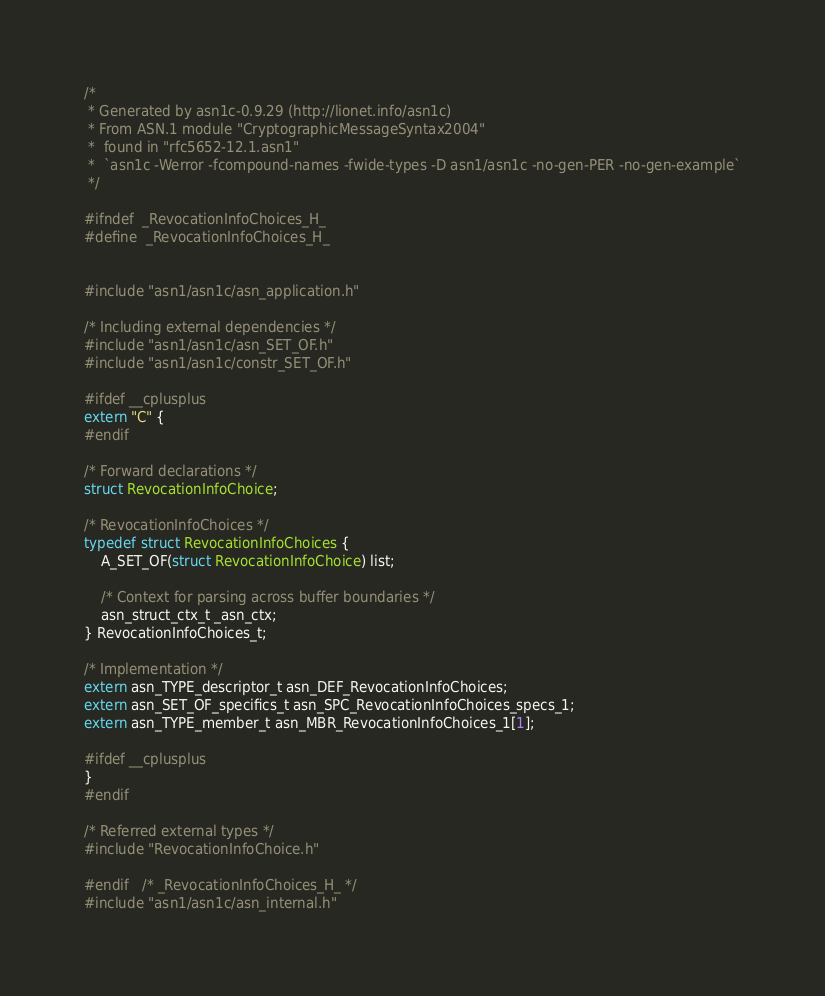<code> <loc_0><loc_0><loc_500><loc_500><_C_>/*
 * Generated by asn1c-0.9.29 (http://lionet.info/asn1c)
 * From ASN.1 module "CryptographicMessageSyntax2004"
 * 	found in "rfc5652-12.1.asn1"
 * 	`asn1c -Werror -fcompound-names -fwide-types -D asn1/asn1c -no-gen-PER -no-gen-example`
 */

#ifndef	_RevocationInfoChoices_H_
#define	_RevocationInfoChoices_H_


#include "asn1/asn1c/asn_application.h"

/* Including external dependencies */
#include "asn1/asn1c/asn_SET_OF.h"
#include "asn1/asn1c/constr_SET_OF.h"

#ifdef __cplusplus
extern "C" {
#endif

/* Forward declarations */
struct RevocationInfoChoice;

/* RevocationInfoChoices */
typedef struct RevocationInfoChoices {
	A_SET_OF(struct RevocationInfoChoice) list;
	
	/* Context for parsing across buffer boundaries */
	asn_struct_ctx_t _asn_ctx;
} RevocationInfoChoices_t;

/* Implementation */
extern asn_TYPE_descriptor_t asn_DEF_RevocationInfoChoices;
extern asn_SET_OF_specifics_t asn_SPC_RevocationInfoChoices_specs_1;
extern asn_TYPE_member_t asn_MBR_RevocationInfoChoices_1[1];

#ifdef __cplusplus
}
#endif

/* Referred external types */
#include "RevocationInfoChoice.h"

#endif	/* _RevocationInfoChoices_H_ */
#include "asn1/asn1c/asn_internal.h"
</code> 